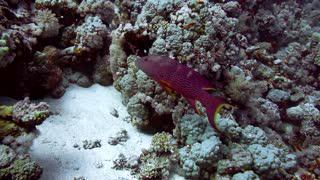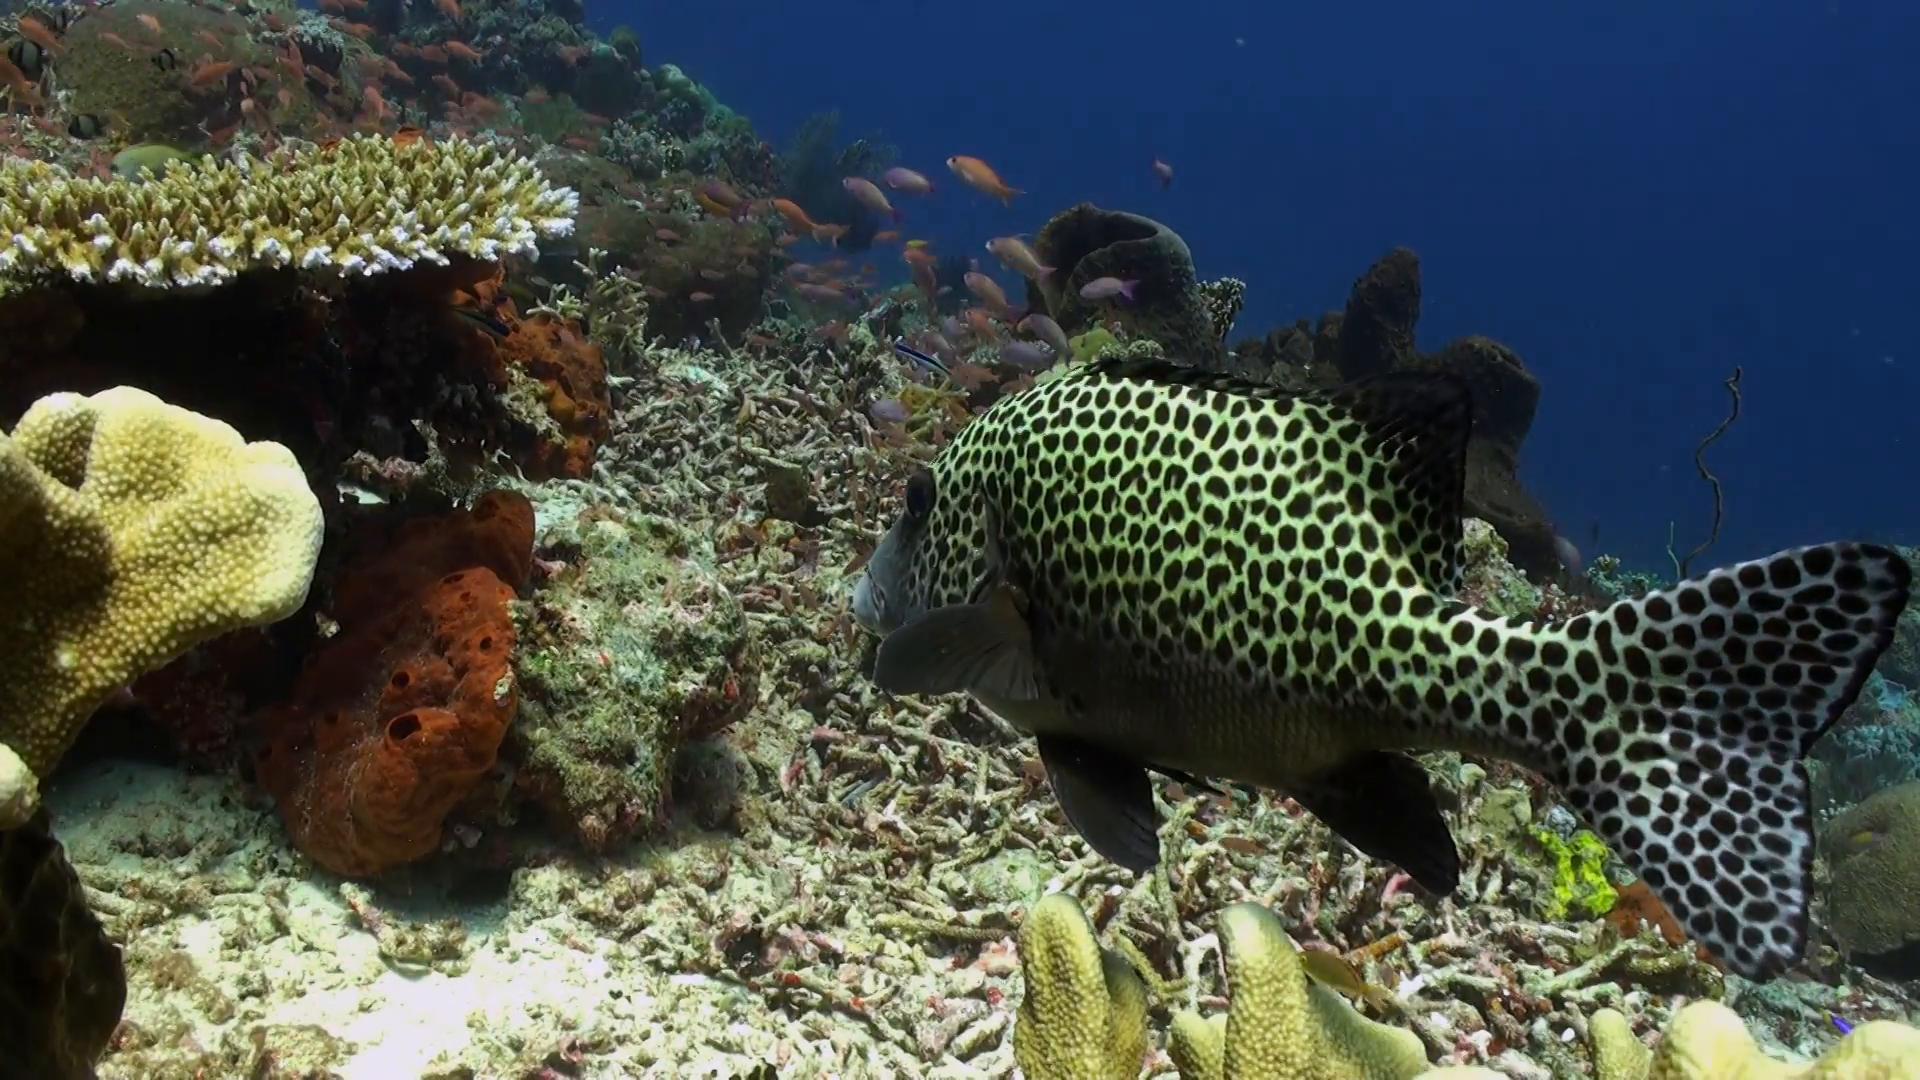The first image is the image on the left, the second image is the image on the right. Evaluate the accuracy of this statement regarding the images: "At least one colorful fish is near the purple-tipped slender tendrils of an anemone in one image.". Is it true? Answer yes or no. No. The first image is the image on the left, the second image is the image on the right. For the images shown, is this caption "There are clown fish in the left image." true? Answer yes or no. No. 